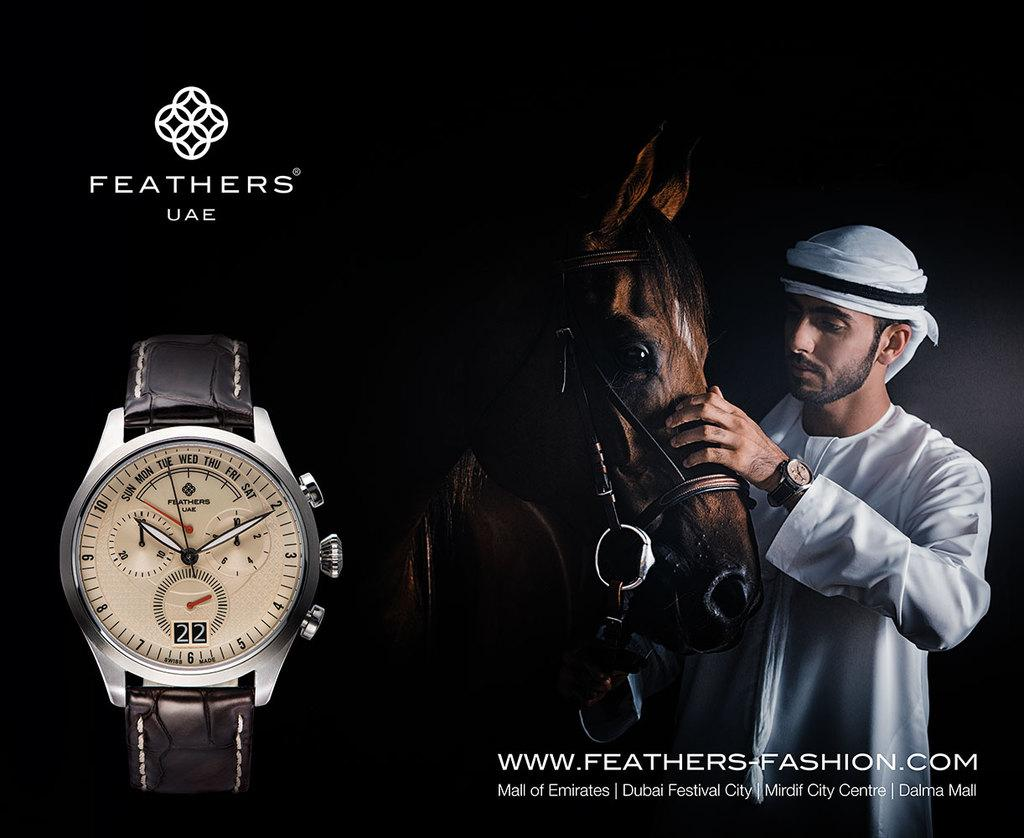<image>
Share a concise interpretation of the image provided. An advertisement for the watch brand Feathers UAE. 